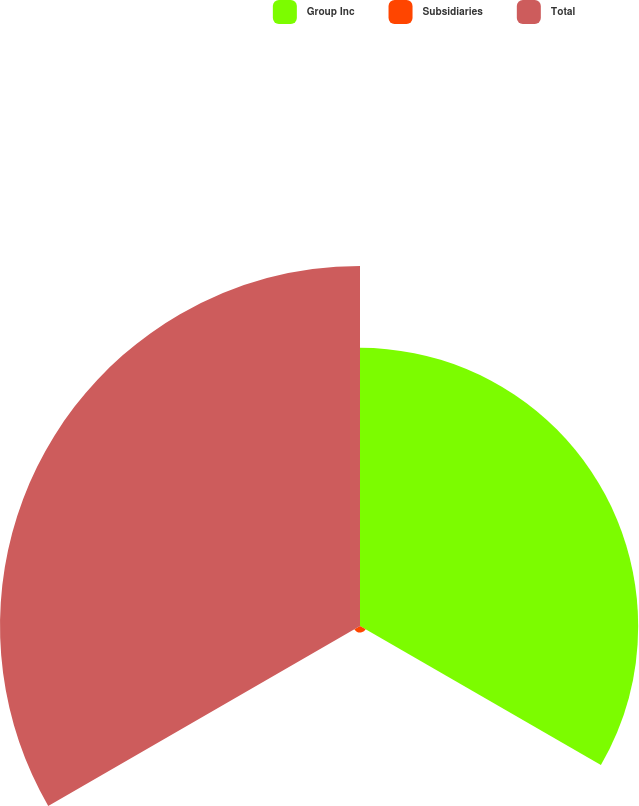<chart> <loc_0><loc_0><loc_500><loc_500><pie_chart><fcel>Group Inc<fcel>Subsidiaries<fcel>Total<nl><fcel>43.14%<fcel>1.02%<fcel>55.83%<nl></chart> 